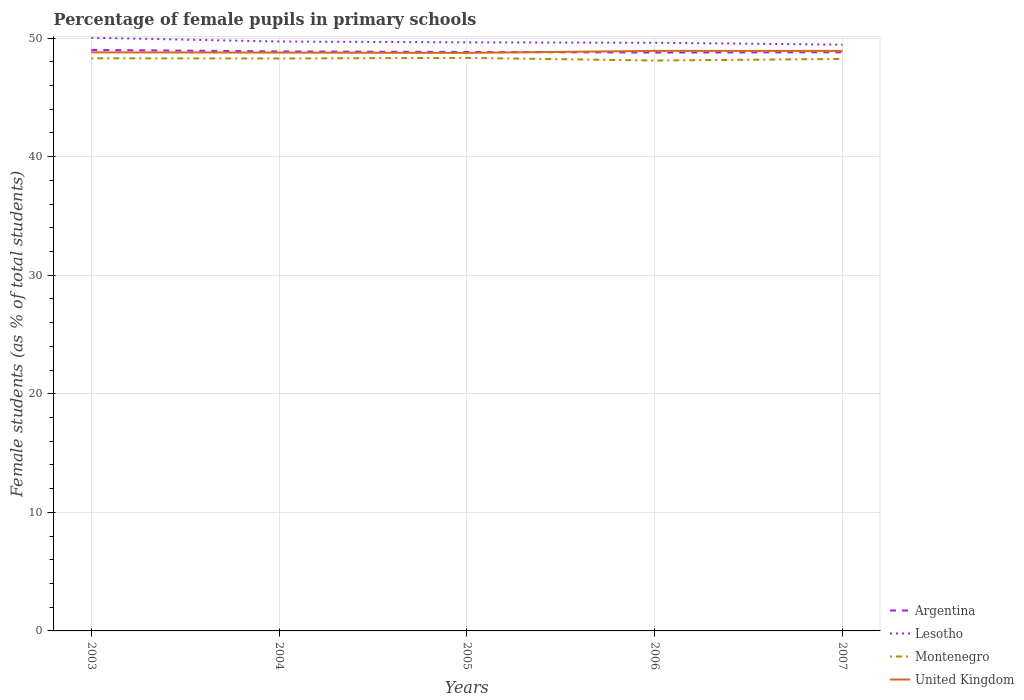How many different coloured lines are there?
Offer a terse response. 4. Is the number of lines equal to the number of legend labels?
Provide a short and direct response. Yes. Across all years, what is the maximum percentage of female pupils in primary schools in Lesotho?
Provide a short and direct response. 49.44. What is the total percentage of female pupils in primary schools in United Kingdom in the graph?
Provide a succinct answer. 0.03. What is the difference between the highest and the second highest percentage of female pupils in primary schools in Lesotho?
Your answer should be very brief. 0.59. Is the percentage of female pupils in primary schools in United Kingdom strictly greater than the percentage of female pupils in primary schools in Argentina over the years?
Keep it short and to the point. No. How many lines are there?
Make the answer very short. 4. What is the difference between two consecutive major ticks on the Y-axis?
Offer a very short reply. 10. Does the graph contain any zero values?
Provide a short and direct response. No. Does the graph contain grids?
Your answer should be very brief. Yes. Where does the legend appear in the graph?
Offer a terse response. Bottom right. What is the title of the graph?
Offer a very short reply. Percentage of female pupils in primary schools. What is the label or title of the X-axis?
Your answer should be compact. Years. What is the label or title of the Y-axis?
Give a very brief answer. Female students (as % of total students). What is the Female students (as % of total students) of Argentina in 2003?
Provide a short and direct response. 49. What is the Female students (as % of total students) of Lesotho in 2003?
Ensure brevity in your answer.  50.03. What is the Female students (as % of total students) of Montenegro in 2003?
Keep it short and to the point. 48.29. What is the Female students (as % of total students) of United Kingdom in 2003?
Make the answer very short. 48.79. What is the Female students (as % of total students) of Argentina in 2004?
Keep it short and to the point. 48.87. What is the Female students (as % of total students) of Lesotho in 2004?
Provide a succinct answer. 49.71. What is the Female students (as % of total students) in Montenegro in 2004?
Ensure brevity in your answer.  48.28. What is the Female students (as % of total students) of United Kingdom in 2004?
Ensure brevity in your answer.  48.77. What is the Female students (as % of total students) of Argentina in 2005?
Keep it short and to the point. 48.82. What is the Female students (as % of total students) of Lesotho in 2005?
Ensure brevity in your answer.  49.63. What is the Female students (as % of total students) of Montenegro in 2005?
Keep it short and to the point. 48.33. What is the Female students (as % of total students) in United Kingdom in 2005?
Your answer should be very brief. 48.75. What is the Female students (as % of total students) of Argentina in 2006?
Give a very brief answer. 48.77. What is the Female students (as % of total students) of Lesotho in 2006?
Provide a short and direct response. 49.6. What is the Female students (as % of total students) of Montenegro in 2006?
Offer a terse response. 48.1. What is the Female students (as % of total students) of United Kingdom in 2006?
Offer a very short reply. 48.92. What is the Female students (as % of total students) of Argentina in 2007?
Offer a very short reply. 48.8. What is the Female students (as % of total students) in Lesotho in 2007?
Your answer should be compact. 49.44. What is the Female students (as % of total students) in Montenegro in 2007?
Offer a very short reply. 48.24. What is the Female students (as % of total students) of United Kingdom in 2007?
Offer a terse response. 48.91. Across all years, what is the maximum Female students (as % of total students) of Argentina?
Offer a very short reply. 49. Across all years, what is the maximum Female students (as % of total students) of Lesotho?
Keep it short and to the point. 50.03. Across all years, what is the maximum Female students (as % of total students) in Montenegro?
Make the answer very short. 48.33. Across all years, what is the maximum Female students (as % of total students) in United Kingdom?
Your answer should be very brief. 48.92. Across all years, what is the minimum Female students (as % of total students) in Argentina?
Your response must be concise. 48.77. Across all years, what is the minimum Female students (as % of total students) in Lesotho?
Provide a succinct answer. 49.44. Across all years, what is the minimum Female students (as % of total students) in Montenegro?
Make the answer very short. 48.1. Across all years, what is the minimum Female students (as % of total students) of United Kingdom?
Make the answer very short. 48.75. What is the total Female students (as % of total students) of Argentina in the graph?
Your response must be concise. 244.27. What is the total Female students (as % of total students) in Lesotho in the graph?
Make the answer very short. 248.41. What is the total Female students (as % of total students) in Montenegro in the graph?
Your response must be concise. 241.23. What is the total Female students (as % of total students) in United Kingdom in the graph?
Make the answer very short. 244.14. What is the difference between the Female students (as % of total students) of Argentina in 2003 and that in 2004?
Offer a very short reply. 0.13. What is the difference between the Female students (as % of total students) in Lesotho in 2003 and that in 2004?
Your response must be concise. 0.32. What is the difference between the Female students (as % of total students) of Montenegro in 2003 and that in 2004?
Give a very brief answer. 0.02. What is the difference between the Female students (as % of total students) in United Kingdom in 2003 and that in 2004?
Provide a short and direct response. 0.02. What is the difference between the Female students (as % of total students) in Argentina in 2003 and that in 2005?
Give a very brief answer. 0.17. What is the difference between the Female students (as % of total students) in Lesotho in 2003 and that in 2005?
Your response must be concise. 0.39. What is the difference between the Female students (as % of total students) of Montenegro in 2003 and that in 2005?
Provide a succinct answer. -0.04. What is the difference between the Female students (as % of total students) in United Kingdom in 2003 and that in 2005?
Make the answer very short. 0.05. What is the difference between the Female students (as % of total students) of Argentina in 2003 and that in 2006?
Provide a succinct answer. 0.23. What is the difference between the Female students (as % of total students) of Lesotho in 2003 and that in 2006?
Make the answer very short. 0.43. What is the difference between the Female students (as % of total students) in Montenegro in 2003 and that in 2006?
Offer a very short reply. 0.19. What is the difference between the Female students (as % of total students) of United Kingdom in 2003 and that in 2006?
Your response must be concise. -0.12. What is the difference between the Female students (as % of total students) of Argentina in 2003 and that in 2007?
Offer a very short reply. 0.2. What is the difference between the Female students (as % of total students) of Lesotho in 2003 and that in 2007?
Your answer should be compact. 0.59. What is the difference between the Female students (as % of total students) in Montenegro in 2003 and that in 2007?
Your response must be concise. 0.06. What is the difference between the Female students (as % of total students) in United Kingdom in 2003 and that in 2007?
Ensure brevity in your answer.  -0.12. What is the difference between the Female students (as % of total students) of Argentina in 2004 and that in 2005?
Provide a short and direct response. 0.05. What is the difference between the Female students (as % of total students) of Lesotho in 2004 and that in 2005?
Provide a succinct answer. 0.07. What is the difference between the Female students (as % of total students) of Montenegro in 2004 and that in 2005?
Your answer should be compact. -0.05. What is the difference between the Female students (as % of total students) of United Kingdom in 2004 and that in 2005?
Make the answer very short. 0.03. What is the difference between the Female students (as % of total students) in Argentina in 2004 and that in 2006?
Give a very brief answer. 0.1. What is the difference between the Female students (as % of total students) of Lesotho in 2004 and that in 2006?
Your answer should be compact. 0.1. What is the difference between the Female students (as % of total students) of Montenegro in 2004 and that in 2006?
Give a very brief answer. 0.17. What is the difference between the Female students (as % of total students) in United Kingdom in 2004 and that in 2006?
Your answer should be very brief. -0.14. What is the difference between the Female students (as % of total students) of Argentina in 2004 and that in 2007?
Your answer should be compact. 0.07. What is the difference between the Female students (as % of total students) in Lesotho in 2004 and that in 2007?
Offer a very short reply. 0.27. What is the difference between the Female students (as % of total students) in Montenegro in 2004 and that in 2007?
Keep it short and to the point. 0.04. What is the difference between the Female students (as % of total students) of United Kingdom in 2004 and that in 2007?
Your answer should be compact. -0.14. What is the difference between the Female students (as % of total students) in Argentina in 2005 and that in 2006?
Offer a terse response. 0.05. What is the difference between the Female students (as % of total students) of Lesotho in 2005 and that in 2006?
Your answer should be very brief. 0.03. What is the difference between the Female students (as % of total students) in Montenegro in 2005 and that in 2006?
Offer a very short reply. 0.22. What is the difference between the Female students (as % of total students) of United Kingdom in 2005 and that in 2006?
Ensure brevity in your answer.  -0.17. What is the difference between the Female students (as % of total students) in Argentina in 2005 and that in 2007?
Your response must be concise. 0.02. What is the difference between the Female students (as % of total students) in Lesotho in 2005 and that in 2007?
Ensure brevity in your answer.  0.19. What is the difference between the Female students (as % of total students) of Montenegro in 2005 and that in 2007?
Ensure brevity in your answer.  0.09. What is the difference between the Female students (as % of total students) of United Kingdom in 2005 and that in 2007?
Offer a very short reply. -0.17. What is the difference between the Female students (as % of total students) of Argentina in 2006 and that in 2007?
Offer a terse response. -0.03. What is the difference between the Female students (as % of total students) of Lesotho in 2006 and that in 2007?
Ensure brevity in your answer.  0.16. What is the difference between the Female students (as % of total students) of Montenegro in 2006 and that in 2007?
Keep it short and to the point. -0.13. What is the difference between the Female students (as % of total students) of United Kingdom in 2006 and that in 2007?
Offer a very short reply. 0. What is the difference between the Female students (as % of total students) in Argentina in 2003 and the Female students (as % of total students) in Lesotho in 2004?
Keep it short and to the point. -0.71. What is the difference between the Female students (as % of total students) in Argentina in 2003 and the Female students (as % of total students) in Montenegro in 2004?
Give a very brief answer. 0.72. What is the difference between the Female students (as % of total students) in Argentina in 2003 and the Female students (as % of total students) in United Kingdom in 2004?
Your response must be concise. 0.23. What is the difference between the Female students (as % of total students) in Lesotho in 2003 and the Female students (as % of total students) in Montenegro in 2004?
Your response must be concise. 1.75. What is the difference between the Female students (as % of total students) in Lesotho in 2003 and the Female students (as % of total students) in United Kingdom in 2004?
Keep it short and to the point. 1.25. What is the difference between the Female students (as % of total students) in Montenegro in 2003 and the Female students (as % of total students) in United Kingdom in 2004?
Give a very brief answer. -0.48. What is the difference between the Female students (as % of total students) in Argentina in 2003 and the Female students (as % of total students) in Lesotho in 2005?
Your response must be concise. -0.64. What is the difference between the Female students (as % of total students) in Argentina in 2003 and the Female students (as % of total students) in Montenegro in 2005?
Ensure brevity in your answer.  0.67. What is the difference between the Female students (as % of total students) in Argentina in 2003 and the Female students (as % of total students) in United Kingdom in 2005?
Your response must be concise. 0.25. What is the difference between the Female students (as % of total students) of Lesotho in 2003 and the Female students (as % of total students) of Montenegro in 2005?
Offer a very short reply. 1.7. What is the difference between the Female students (as % of total students) of Lesotho in 2003 and the Female students (as % of total students) of United Kingdom in 2005?
Give a very brief answer. 1.28. What is the difference between the Female students (as % of total students) of Montenegro in 2003 and the Female students (as % of total students) of United Kingdom in 2005?
Your answer should be compact. -0.46. What is the difference between the Female students (as % of total students) in Argentina in 2003 and the Female students (as % of total students) in Lesotho in 2006?
Keep it short and to the point. -0.6. What is the difference between the Female students (as % of total students) in Argentina in 2003 and the Female students (as % of total students) in Montenegro in 2006?
Your response must be concise. 0.9. What is the difference between the Female students (as % of total students) of Argentina in 2003 and the Female students (as % of total students) of United Kingdom in 2006?
Your answer should be compact. 0.08. What is the difference between the Female students (as % of total students) of Lesotho in 2003 and the Female students (as % of total students) of Montenegro in 2006?
Keep it short and to the point. 1.92. What is the difference between the Female students (as % of total students) of Montenegro in 2003 and the Female students (as % of total students) of United Kingdom in 2006?
Provide a short and direct response. -0.62. What is the difference between the Female students (as % of total students) in Argentina in 2003 and the Female students (as % of total students) in Lesotho in 2007?
Your answer should be compact. -0.44. What is the difference between the Female students (as % of total students) of Argentina in 2003 and the Female students (as % of total students) of Montenegro in 2007?
Offer a very short reply. 0.76. What is the difference between the Female students (as % of total students) in Argentina in 2003 and the Female students (as % of total students) in United Kingdom in 2007?
Your answer should be very brief. 0.09. What is the difference between the Female students (as % of total students) of Lesotho in 2003 and the Female students (as % of total students) of Montenegro in 2007?
Ensure brevity in your answer.  1.79. What is the difference between the Female students (as % of total students) in Lesotho in 2003 and the Female students (as % of total students) in United Kingdom in 2007?
Offer a very short reply. 1.11. What is the difference between the Female students (as % of total students) in Montenegro in 2003 and the Female students (as % of total students) in United Kingdom in 2007?
Offer a terse response. -0.62. What is the difference between the Female students (as % of total students) in Argentina in 2004 and the Female students (as % of total students) in Lesotho in 2005?
Ensure brevity in your answer.  -0.76. What is the difference between the Female students (as % of total students) of Argentina in 2004 and the Female students (as % of total students) of Montenegro in 2005?
Make the answer very short. 0.55. What is the difference between the Female students (as % of total students) of Argentina in 2004 and the Female students (as % of total students) of United Kingdom in 2005?
Your answer should be very brief. 0.13. What is the difference between the Female students (as % of total students) in Lesotho in 2004 and the Female students (as % of total students) in Montenegro in 2005?
Ensure brevity in your answer.  1.38. What is the difference between the Female students (as % of total students) of Lesotho in 2004 and the Female students (as % of total students) of United Kingdom in 2005?
Keep it short and to the point. 0.96. What is the difference between the Female students (as % of total students) in Montenegro in 2004 and the Female students (as % of total students) in United Kingdom in 2005?
Make the answer very short. -0.47. What is the difference between the Female students (as % of total students) in Argentina in 2004 and the Female students (as % of total students) in Lesotho in 2006?
Provide a short and direct response. -0.73. What is the difference between the Female students (as % of total students) in Argentina in 2004 and the Female students (as % of total students) in Montenegro in 2006?
Ensure brevity in your answer.  0.77. What is the difference between the Female students (as % of total students) of Argentina in 2004 and the Female students (as % of total students) of United Kingdom in 2006?
Provide a succinct answer. -0.04. What is the difference between the Female students (as % of total students) in Lesotho in 2004 and the Female students (as % of total students) in Montenegro in 2006?
Give a very brief answer. 1.6. What is the difference between the Female students (as % of total students) in Lesotho in 2004 and the Female students (as % of total students) in United Kingdom in 2006?
Your answer should be very brief. 0.79. What is the difference between the Female students (as % of total students) of Montenegro in 2004 and the Female students (as % of total students) of United Kingdom in 2006?
Your response must be concise. -0.64. What is the difference between the Female students (as % of total students) in Argentina in 2004 and the Female students (as % of total students) in Lesotho in 2007?
Keep it short and to the point. -0.57. What is the difference between the Female students (as % of total students) of Argentina in 2004 and the Female students (as % of total students) of Montenegro in 2007?
Give a very brief answer. 0.64. What is the difference between the Female students (as % of total students) in Argentina in 2004 and the Female students (as % of total students) in United Kingdom in 2007?
Your answer should be compact. -0.04. What is the difference between the Female students (as % of total students) in Lesotho in 2004 and the Female students (as % of total students) in Montenegro in 2007?
Your response must be concise. 1.47. What is the difference between the Female students (as % of total students) of Lesotho in 2004 and the Female students (as % of total students) of United Kingdom in 2007?
Give a very brief answer. 0.79. What is the difference between the Female students (as % of total students) of Montenegro in 2004 and the Female students (as % of total students) of United Kingdom in 2007?
Provide a short and direct response. -0.64. What is the difference between the Female students (as % of total students) of Argentina in 2005 and the Female students (as % of total students) of Lesotho in 2006?
Provide a short and direct response. -0.78. What is the difference between the Female students (as % of total students) of Argentina in 2005 and the Female students (as % of total students) of Montenegro in 2006?
Keep it short and to the point. 0.72. What is the difference between the Female students (as % of total students) in Argentina in 2005 and the Female students (as % of total students) in United Kingdom in 2006?
Provide a short and direct response. -0.09. What is the difference between the Female students (as % of total students) in Lesotho in 2005 and the Female students (as % of total students) in Montenegro in 2006?
Ensure brevity in your answer.  1.53. What is the difference between the Female students (as % of total students) in Lesotho in 2005 and the Female students (as % of total students) in United Kingdom in 2006?
Your response must be concise. 0.72. What is the difference between the Female students (as % of total students) in Montenegro in 2005 and the Female students (as % of total students) in United Kingdom in 2006?
Your response must be concise. -0.59. What is the difference between the Female students (as % of total students) in Argentina in 2005 and the Female students (as % of total students) in Lesotho in 2007?
Provide a succinct answer. -0.62. What is the difference between the Female students (as % of total students) in Argentina in 2005 and the Female students (as % of total students) in Montenegro in 2007?
Make the answer very short. 0.59. What is the difference between the Female students (as % of total students) of Argentina in 2005 and the Female students (as % of total students) of United Kingdom in 2007?
Keep it short and to the point. -0.09. What is the difference between the Female students (as % of total students) in Lesotho in 2005 and the Female students (as % of total students) in Montenegro in 2007?
Your answer should be compact. 1.4. What is the difference between the Female students (as % of total students) in Lesotho in 2005 and the Female students (as % of total students) in United Kingdom in 2007?
Provide a short and direct response. 0.72. What is the difference between the Female students (as % of total students) of Montenegro in 2005 and the Female students (as % of total students) of United Kingdom in 2007?
Make the answer very short. -0.59. What is the difference between the Female students (as % of total students) in Argentina in 2006 and the Female students (as % of total students) in Lesotho in 2007?
Give a very brief answer. -0.67. What is the difference between the Female students (as % of total students) of Argentina in 2006 and the Female students (as % of total students) of Montenegro in 2007?
Provide a short and direct response. 0.54. What is the difference between the Female students (as % of total students) in Argentina in 2006 and the Female students (as % of total students) in United Kingdom in 2007?
Offer a terse response. -0.14. What is the difference between the Female students (as % of total students) in Lesotho in 2006 and the Female students (as % of total students) in Montenegro in 2007?
Offer a very short reply. 1.37. What is the difference between the Female students (as % of total students) in Lesotho in 2006 and the Female students (as % of total students) in United Kingdom in 2007?
Provide a succinct answer. 0.69. What is the difference between the Female students (as % of total students) of Montenegro in 2006 and the Female students (as % of total students) of United Kingdom in 2007?
Your answer should be compact. -0.81. What is the average Female students (as % of total students) of Argentina per year?
Make the answer very short. 48.85. What is the average Female students (as % of total students) in Lesotho per year?
Give a very brief answer. 49.68. What is the average Female students (as % of total students) in Montenegro per year?
Ensure brevity in your answer.  48.25. What is the average Female students (as % of total students) of United Kingdom per year?
Give a very brief answer. 48.83. In the year 2003, what is the difference between the Female students (as % of total students) in Argentina and Female students (as % of total students) in Lesotho?
Your answer should be compact. -1.03. In the year 2003, what is the difference between the Female students (as % of total students) in Argentina and Female students (as % of total students) in Montenegro?
Your answer should be very brief. 0.71. In the year 2003, what is the difference between the Female students (as % of total students) in Argentina and Female students (as % of total students) in United Kingdom?
Your answer should be compact. 0.21. In the year 2003, what is the difference between the Female students (as % of total students) of Lesotho and Female students (as % of total students) of Montenegro?
Your answer should be very brief. 1.74. In the year 2003, what is the difference between the Female students (as % of total students) in Lesotho and Female students (as % of total students) in United Kingdom?
Provide a succinct answer. 1.23. In the year 2003, what is the difference between the Female students (as % of total students) of Montenegro and Female students (as % of total students) of United Kingdom?
Ensure brevity in your answer.  -0.5. In the year 2004, what is the difference between the Female students (as % of total students) of Argentina and Female students (as % of total students) of Lesotho?
Your answer should be compact. -0.83. In the year 2004, what is the difference between the Female students (as % of total students) in Argentina and Female students (as % of total students) in Montenegro?
Offer a very short reply. 0.6. In the year 2004, what is the difference between the Female students (as % of total students) in Argentina and Female students (as % of total students) in United Kingdom?
Your answer should be compact. 0.1. In the year 2004, what is the difference between the Female students (as % of total students) of Lesotho and Female students (as % of total students) of Montenegro?
Provide a succinct answer. 1.43. In the year 2004, what is the difference between the Female students (as % of total students) in Lesotho and Female students (as % of total students) in United Kingdom?
Keep it short and to the point. 0.93. In the year 2004, what is the difference between the Female students (as % of total students) in Montenegro and Female students (as % of total students) in United Kingdom?
Offer a terse response. -0.5. In the year 2005, what is the difference between the Female students (as % of total students) in Argentina and Female students (as % of total students) in Lesotho?
Keep it short and to the point. -0.81. In the year 2005, what is the difference between the Female students (as % of total students) in Argentina and Female students (as % of total students) in Montenegro?
Your response must be concise. 0.5. In the year 2005, what is the difference between the Female students (as % of total students) of Argentina and Female students (as % of total students) of United Kingdom?
Make the answer very short. 0.08. In the year 2005, what is the difference between the Female students (as % of total students) of Lesotho and Female students (as % of total students) of Montenegro?
Give a very brief answer. 1.31. In the year 2005, what is the difference between the Female students (as % of total students) in Lesotho and Female students (as % of total students) in United Kingdom?
Keep it short and to the point. 0.89. In the year 2005, what is the difference between the Female students (as % of total students) in Montenegro and Female students (as % of total students) in United Kingdom?
Your response must be concise. -0.42. In the year 2006, what is the difference between the Female students (as % of total students) in Argentina and Female students (as % of total students) in Lesotho?
Keep it short and to the point. -0.83. In the year 2006, what is the difference between the Female students (as % of total students) of Argentina and Female students (as % of total students) of Montenegro?
Your answer should be very brief. 0.67. In the year 2006, what is the difference between the Female students (as % of total students) in Argentina and Female students (as % of total students) in United Kingdom?
Provide a short and direct response. -0.14. In the year 2006, what is the difference between the Female students (as % of total students) of Lesotho and Female students (as % of total students) of Montenegro?
Your answer should be very brief. 1.5. In the year 2006, what is the difference between the Female students (as % of total students) of Lesotho and Female students (as % of total students) of United Kingdom?
Provide a short and direct response. 0.69. In the year 2006, what is the difference between the Female students (as % of total students) in Montenegro and Female students (as % of total students) in United Kingdom?
Your response must be concise. -0.81. In the year 2007, what is the difference between the Female students (as % of total students) in Argentina and Female students (as % of total students) in Lesotho?
Your answer should be very brief. -0.64. In the year 2007, what is the difference between the Female students (as % of total students) in Argentina and Female students (as % of total students) in Montenegro?
Your response must be concise. 0.56. In the year 2007, what is the difference between the Female students (as % of total students) of Argentina and Female students (as % of total students) of United Kingdom?
Your response must be concise. -0.11. In the year 2007, what is the difference between the Female students (as % of total students) in Lesotho and Female students (as % of total students) in Montenegro?
Your answer should be very brief. 1.2. In the year 2007, what is the difference between the Female students (as % of total students) in Lesotho and Female students (as % of total students) in United Kingdom?
Give a very brief answer. 0.53. In the year 2007, what is the difference between the Female students (as % of total students) of Montenegro and Female students (as % of total students) of United Kingdom?
Provide a short and direct response. -0.68. What is the ratio of the Female students (as % of total students) in Argentina in 2003 to that in 2004?
Your answer should be compact. 1. What is the ratio of the Female students (as % of total students) of Lesotho in 2003 to that in 2004?
Ensure brevity in your answer.  1.01. What is the ratio of the Female students (as % of total students) of Lesotho in 2003 to that in 2005?
Provide a succinct answer. 1.01. What is the ratio of the Female students (as % of total students) of Lesotho in 2003 to that in 2006?
Make the answer very short. 1.01. What is the ratio of the Female students (as % of total students) in Montenegro in 2003 to that in 2006?
Offer a very short reply. 1. What is the ratio of the Female students (as % of total students) of United Kingdom in 2003 to that in 2006?
Give a very brief answer. 1. What is the ratio of the Female students (as % of total students) in Argentina in 2003 to that in 2007?
Provide a succinct answer. 1. What is the ratio of the Female students (as % of total students) of Lesotho in 2003 to that in 2007?
Offer a terse response. 1.01. What is the ratio of the Female students (as % of total students) in United Kingdom in 2003 to that in 2007?
Offer a very short reply. 1. What is the ratio of the Female students (as % of total students) in Montenegro in 2004 to that in 2005?
Ensure brevity in your answer.  1. What is the ratio of the Female students (as % of total students) of United Kingdom in 2004 to that in 2006?
Your answer should be compact. 1. What is the ratio of the Female students (as % of total students) of Lesotho in 2004 to that in 2007?
Keep it short and to the point. 1.01. What is the ratio of the Female students (as % of total students) of Montenegro in 2004 to that in 2007?
Offer a terse response. 1. What is the ratio of the Female students (as % of total students) of United Kingdom in 2004 to that in 2007?
Provide a succinct answer. 1. What is the ratio of the Female students (as % of total students) in Argentina in 2005 to that in 2006?
Keep it short and to the point. 1. What is the ratio of the Female students (as % of total students) in Lesotho in 2005 to that in 2006?
Your answer should be compact. 1. What is the ratio of the Female students (as % of total students) in United Kingdom in 2005 to that in 2006?
Provide a short and direct response. 1. What is the ratio of the Female students (as % of total students) of Argentina in 2005 to that in 2007?
Offer a terse response. 1. What is the ratio of the Female students (as % of total students) of Lesotho in 2005 to that in 2007?
Make the answer very short. 1. What is the ratio of the Female students (as % of total students) in United Kingdom in 2005 to that in 2007?
Provide a succinct answer. 1. What is the ratio of the Female students (as % of total students) of Lesotho in 2006 to that in 2007?
Your response must be concise. 1. What is the ratio of the Female students (as % of total students) in Montenegro in 2006 to that in 2007?
Provide a short and direct response. 1. What is the ratio of the Female students (as % of total students) of United Kingdom in 2006 to that in 2007?
Your answer should be very brief. 1. What is the difference between the highest and the second highest Female students (as % of total students) in Argentina?
Ensure brevity in your answer.  0.13. What is the difference between the highest and the second highest Female students (as % of total students) of Lesotho?
Make the answer very short. 0.32. What is the difference between the highest and the second highest Female students (as % of total students) in Montenegro?
Ensure brevity in your answer.  0.04. What is the difference between the highest and the second highest Female students (as % of total students) of United Kingdom?
Make the answer very short. 0. What is the difference between the highest and the lowest Female students (as % of total students) of Argentina?
Keep it short and to the point. 0.23. What is the difference between the highest and the lowest Female students (as % of total students) in Lesotho?
Offer a very short reply. 0.59. What is the difference between the highest and the lowest Female students (as % of total students) in Montenegro?
Your answer should be compact. 0.22. What is the difference between the highest and the lowest Female students (as % of total students) of United Kingdom?
Keep it short and to the point. 0.17. 